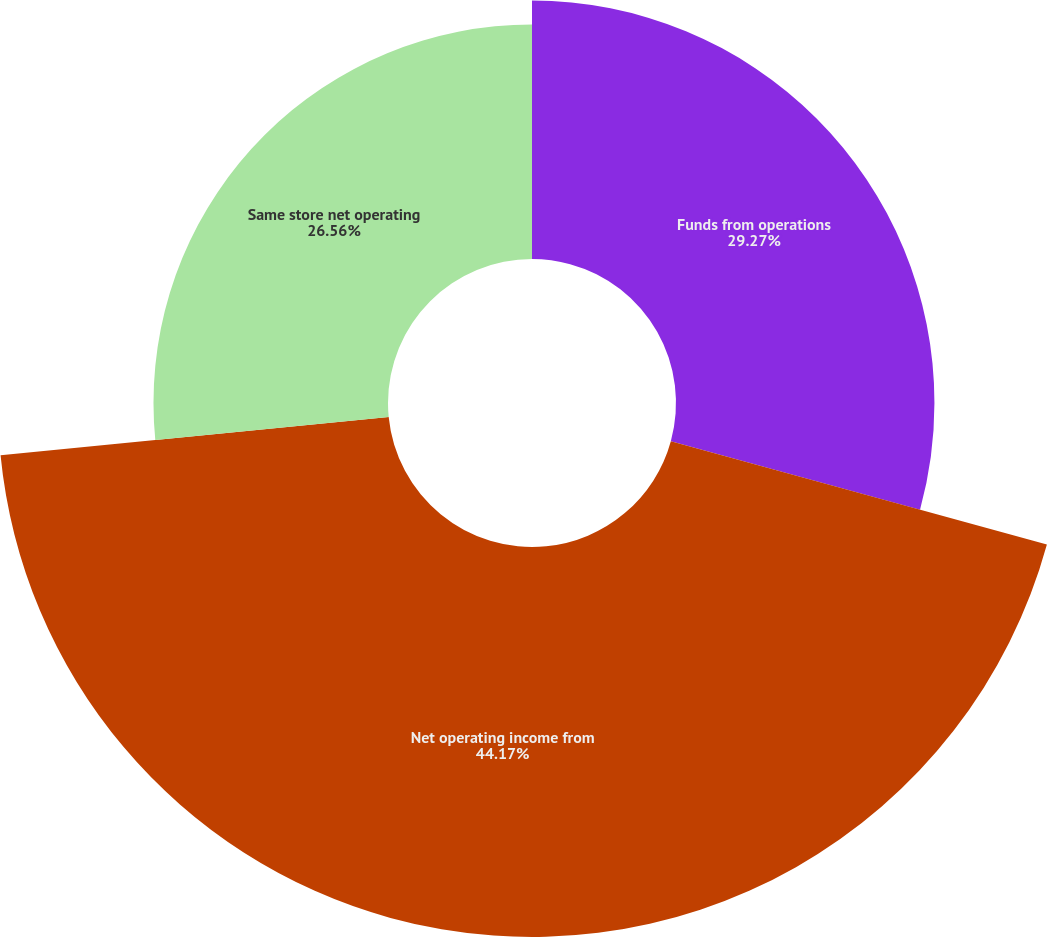<chart> <loc_0><loc_0><loc_500><loc_500><pie_chart><fcel>Funds from operations<fcel>Net operating income from<fcel>Same store net operating<nl><fcel>29.27%<fcel>44.17%<fcel>26.56%<nl></chart> 